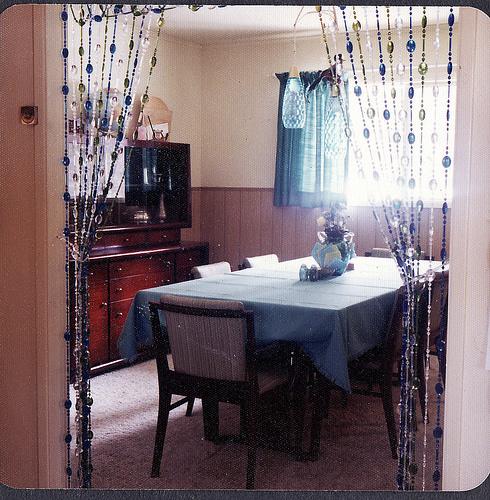What room is shown?
Be succinct. Dining room. Are these walls in disrepair?
Write a very short answer. No. How many chairs can you see?
Be succinct. 6. Is the window open?
Short answer required. Yes. 